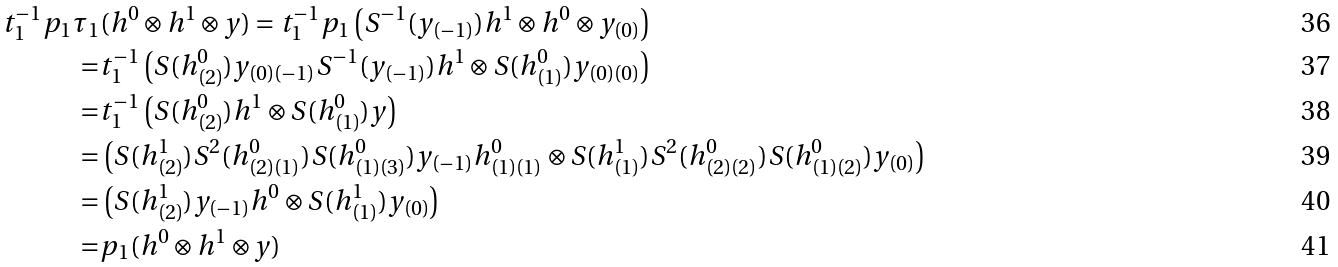<formula> <loc_0><loc_0><loc_500><loc_500>t _ { 1 } ^ { - 1 } p _ { 1 } \tau _ { 1 } & ( h ^ { 0 } \otimes h ^ { 1 } \otimes y ) = t _ { 1 } ^ { - 1 } p _ { 1 } \left ( S ^ { - 1 } ( y _ { ( - 1 ) } ) h ^ { 1 } \otimes h ^ { 0 } \otimes y _ { ( 0 ) } \right ) \\ = & t _ { 1 } ^ { - 1 } \left ( S ( h ^ { 0 } _ { ( 2 ) } ) y _ { ( 0 ) ( - 1 ) } S ^ { - 1 } ( y _ { ( - 1 ) } ) h ^ { 1 } \otimes S ( h ^ { 0 } _ { ( 1 ) } ) y _ { ( 0 ) ( 0 ) } \right ) \\ = & t _ { 1 } ^ { - 1 } \left ( S ( h ^ { 0 } _ { ( 2 ) } ) h ^ { 1 } \otimes S ( h ^ { 0 } _ { ( 1 ) } ) y \right ) \\ = & \left ( S ( h ^ { 1 } _ { ( 2 ) } ) S ^ { 2 } ( h ^ { 0 } _ { ( 2 ) ( 1 ) } ) S ( h ^ { 0 } _ { ( 1 ) ( 3 ) } ) y _ { ( - 1 ) } h ^ { 0 } _ { ( 1 ) ( 1 ) } \otimes S ( h ^ { 1 } _ { ( 1 ) } ) S ^ { 2 } ( h ^ { 0 } _ { ( 2 ) ( 2 ) } ) S ( h ^ { 0 } _ { ( 1 ) ( 2 ) } ) y _ { ( 0 ) } \right ) \\ = & \left ( S ( h ^ { 1 } _ { ( 2 ) } ) y _ { ( - 1 ) } h ^ { 0 } \otimes S ( h ^ { 1 } _ { ( 1 ) } ) y _ { ( 0 ) } \right ) \\ = & p _ { 1 } ( h ^ { 0 } \otimes h ^ { 1 } \otimes y )</formula> 